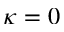Convert formula to latex. <formula><loc_0><loc_0><loc_500><loc_500>\kappa = 0</formula> 